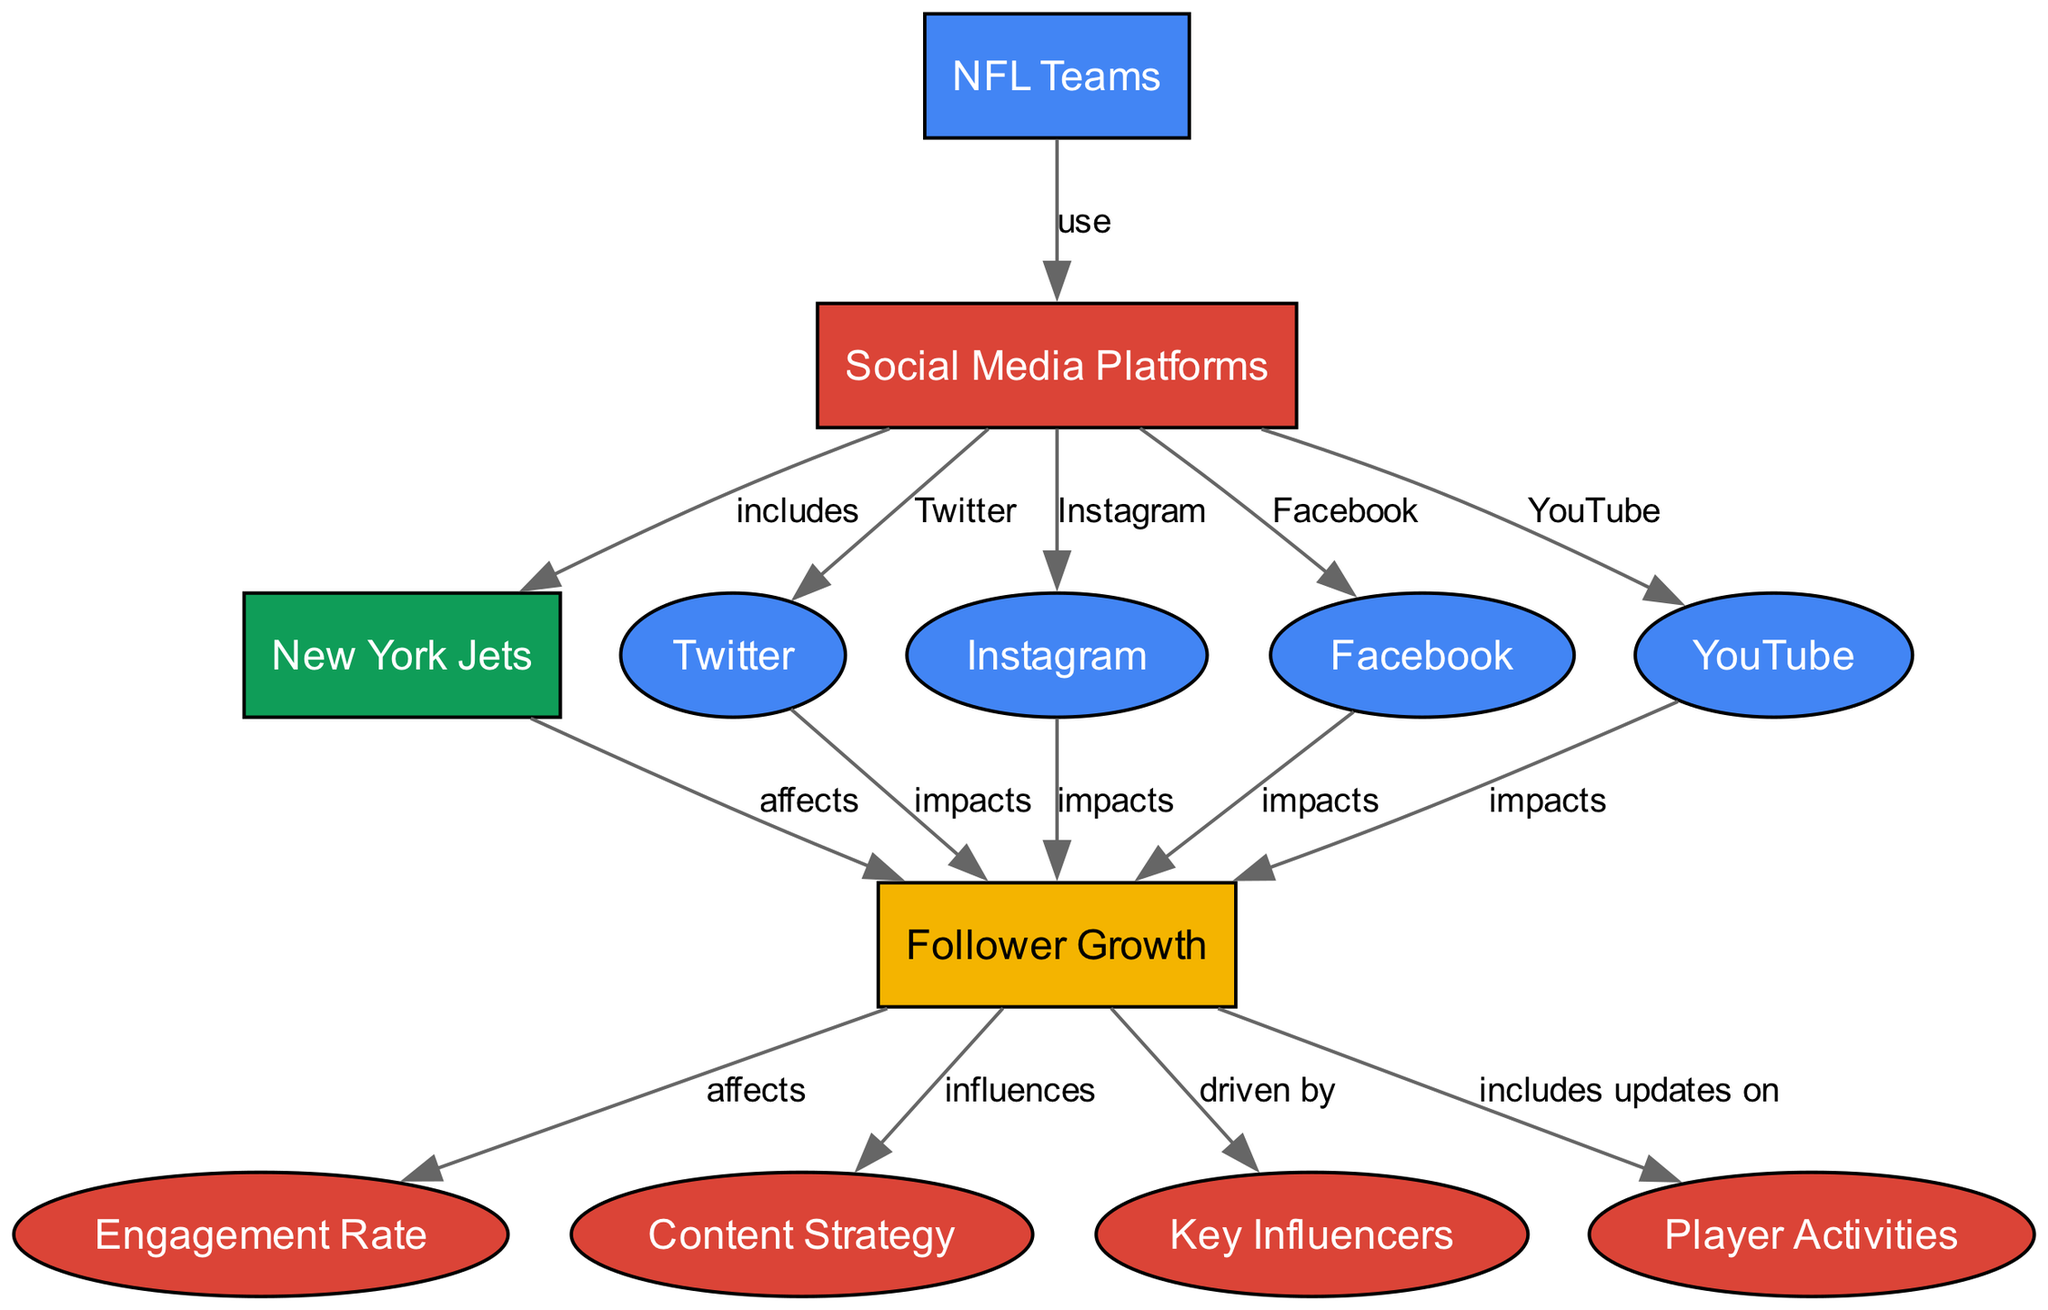What are the social media platforms represented in the diagram? The nodes representing social media platforms are linked from the "NFL Teams" node and include Twitter, Instagram, Facebook, and YouTube.
Answer: Twitter, Instagram, Facebook, YouTube How many nodes are there in total? By counting the number of unique nodes represented in the diagram, which are NFL Teams, Social Media Platforms, Follower Growth, New York Jets, and the individual platforms and related concepts, there are a total of 12 nodes.
Answer: 12 What is the relationship between the New York Jets and Follower Growth? The edge shows that the New York Jets affect Follower Growth, indicating a direct influence of this specific team on its increasing follower count.
Answer: affects Which social media platform has the most direct impact on Follower Growth? Each platform (Twitter, Instagram, Facebook, YouTube) has a direct edge labeled "impacts" leading to Follower Growth. Since they all have the same direct relationship, they equally impact it.
Answer: All platforms How does Follower Growth influence Engagement Rate? The edge shows that Follower Growth affects Engagement Rate, meaning that as follower count increases, so too does engagement rate, indicating a positive correlation.
Answer: affects What are the components that drive Follower Growth according to the diagram? The components driving Follower Growth include Content Strategy and Key Influencers, which both have direct edges leading to Follower Growth, indicating their roles in enhancing overall numbers.
Answer: Content Strategy, Key Influencers Which node represents the specific team mentioned in the diagram? The node labeled "New York Jets" is the specific NFL team noted in the diagram, linked to the broader context of social media influence.
Answer: New York Jets What is the connection between social media platforms and NFL teams? The edge labeled "use" indicates that NFL teams utilize social media platforms as part of their engagement and marketing strategies.
Answer: use What types of updates are included under Follower Growth? The diagram indicates that Follower Growth includes updates on Player Activities, suggesting that player involvement in social media is a contributing factor to follower increase.
Answer: Player Activities 